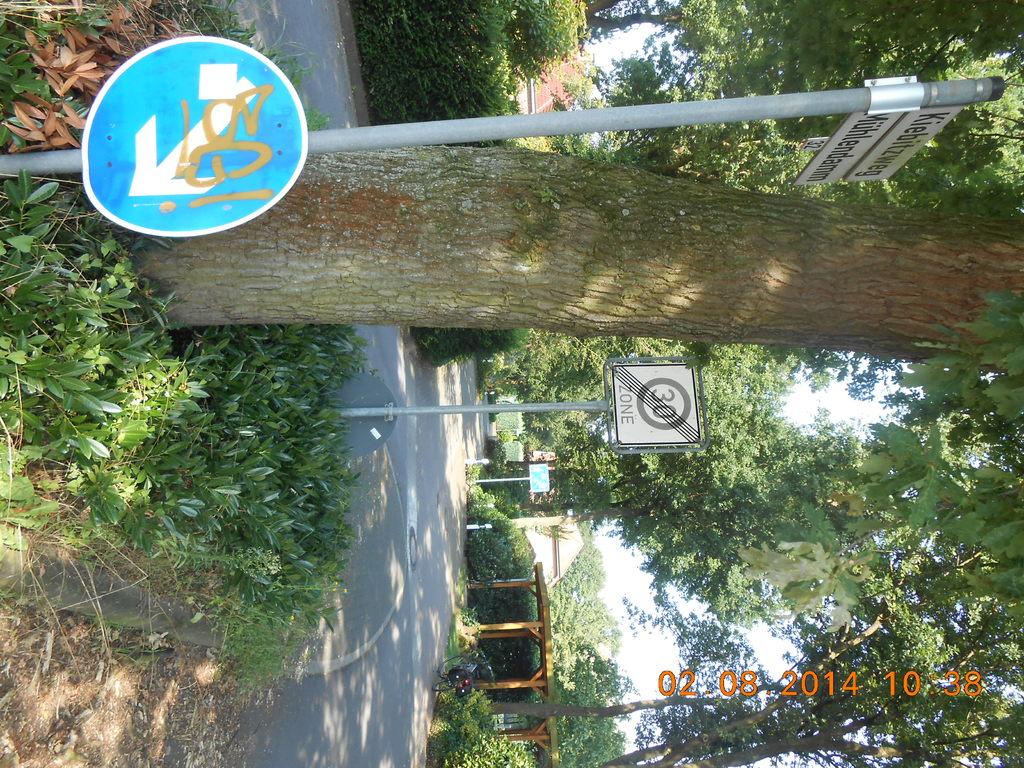What number are on the sign?
Your answer should be compact. 30. What date was the photo taken?
Your response must be concise. 02-08-2014. 